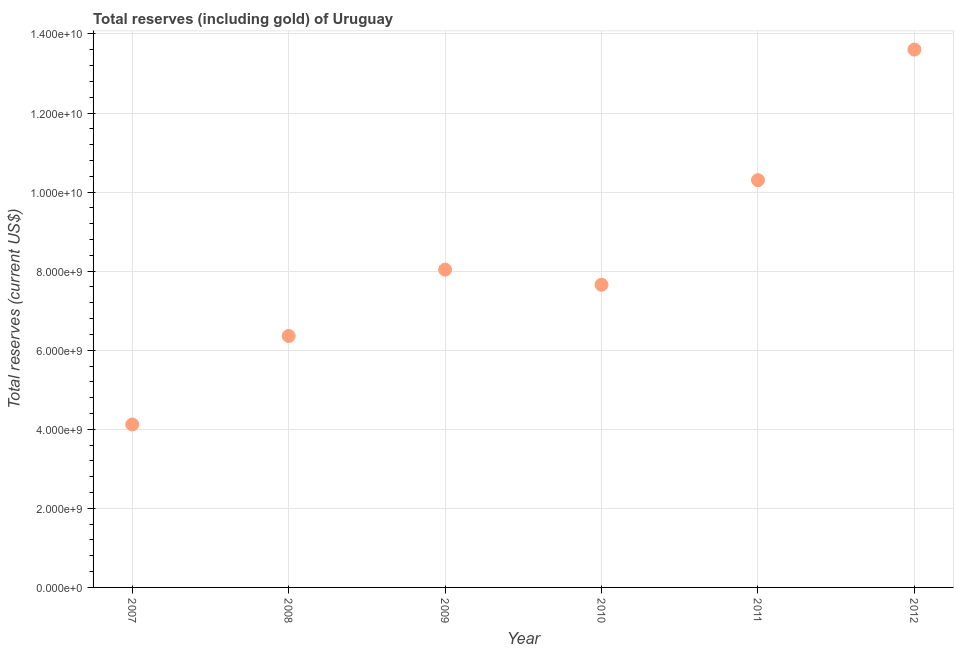What is the total reserves (including gold) in 2007?
Give a very brief answer. 4.12e+09. Across all years, what is the maximum total reserves (including gold)?
Ensure brevity in your answer.  1.36e+1. Across all years, what is the minimum total reserves (including gold)?
Your answer should be compact. 4.12e+09. In which year was the total reserves (including gold) minimum?
Give a very brief answer. 2007. What is the sum of the total reserves (including gold)?
Offer a terse response. 5.01e+1. What is the difference between the total reserves (including gold) in 2007 and 2009?
Your response must be concise. -3.92e+09. What is the average total reserves (including gold) per year?
Your answer should be compact. 8.35e+09. What is the median total reserves (including gold)?
Your answer should be very brief. 7.85e+09. Do a majority of the years between 2011 and 2008 (inclusive) have total reserves (including gold) greater than 6800000000 US$?
Your response must be concise. Yes. What is the ratio of the total reserves (including gold) in 2008 to that in 2011?
Provide a short and direct response. 0.62. Is the difference between the total reserves (including gold) in 2009 and 2012 greater than the difference between any two years?
Offer a terse response. No. What is the difference between the highest and the second highest total reserves (including gold)?
Offer a very short reply. 3.30e+09. What is the difference between the highest and the lowest total reserves (including gold)?
Ensure brevity in your answer.  9.48e+09. Does the total reserves (including gold) monotonically increase over the years?
Ensure brevity in your answer.  No. Does the graph contain any zero values?
Provide a succinct answer. No. What is the title of the graph?
Give a very brief answer. Total reserves (including gold) of Uruguay. What is the label or title of the Y-axis?
Offer a terse response. Total reserves (current US$). What is the Total reserves (current US$) in 2007?
Offer a terse response. 4.12e+09. What is the Total reserves (current US$) in 2008?
Offer a very short reply. 6.36e+09. What is the Total reserves (current US$) in 2009?
Keep it short and to the point. 8.04e+09. What is the Total reserves (current US$) in 2010?
Keep it short and to the point. 7.66e+09. What is the Total reserves (current US$) in 2011?
Ensure brevity in your answer.  1.03e+1. What is the Total reserves (current US$) in 2012?
Keep it short and to the point. 1.36e+1. What is the difference between the Total reserves (current US$) in 2007 and 2008?
Provide a short and direct response. -2.24e+09. What is the difference between the Total reserves (current US$) in 2007 and 2009?
Ensure brevity in your answer.  -3.92e+09. What is the difference between the Total reserves (current US$) in 2007 and 2010?
Give a very brief answer. -3.53e+09. What is the difference between the Total reserves (current US$) in 2007 and 2011?
Provide a succinct answer. -6.18e+09. What is the difference between the Total reserves (current US$) in 2007 and 2012?
Offer a very short reply. -9.48e+09. What is the difference between the Total reserves (current US$) in 2008 and 2009?
Provide a succinct answer. -1.68e+09. What is the difference between the Total reserves (current US$) in 2008 and 2010?
Offer a very short reply. -1.30e+09. What is the difference between the Total reserves (current US$) in 2008 and 2011?
Make the answer very short. -3.94e+09. What is the difference between the Total reserves (current US$) in 2008 and 2012?
Offer a very short reply. -7.24e+09. What is the difference between the Total reserves (current US$) in 2009 and 2010?
Your answer should be very brief. 3.82e+08. What is the difference between the Total reserves (current US$) in 2009 and 2011?
Provide a short and direct response. -2.26e+09. What is the difference between the Total reserves (current US$) in 2009 and 2012?
Give a very brief answer. -5.57e+09. What is the difference between the Total reserves (current US$) in 2010 and 2011?
Offer a very short reply. -2.65e+09. What is the difference between the Total reserves (current US$) in 2010 and 2012?
Your response must be concise. -5.95e+09. What is the difference between the Total reserves (current US$) in 2011 and 2012?
Give a very brief answer. -3.30e+09. What is the ratio of the Total reserves (current US$) in 2007 to that in 2008?
Your answer should be compact. 0.65. What is the ratio of the Total reserves (current US$) in 2007 to that in 2009?
Your answer should be very brief. 0.51. What is the ratio of the Total reserves (current US$) in 2007 to that in 2010?
Your answer should be compact. 0.54. What is the ratio of the Total reserves (current US$) in 2007 to that in 2012?
Your response must be concise. 0.3. What is the ratio of the Total reserves (current US$) in 2008 to that in 2009?
Your response must be concise. 0.79. What is the ratio of the Total reserves (current US$) in 2008 to that in 2010?
Offer a terse response. 0.83. What is the ratio of the Total reserves (current US$) in 2008 to that in 2011?
Offer a terse response. 0.62. What is the ratio of the Total reserves (current US$) in 2008 to that in 2012?
Provide a succinct answer. 0.47. What is the ratio of the Total reserves (current US$) in 2009 to that in 2011?
Offer a very short reply. 0.78. What is the ratio of the Total reserves (current US$) in 2009 to that in 2012?
Make the answer very short. 0.59. What is the ratio of the Total reserves (current US$) in 2010 to that in 2011?
Your answer should be very brief. 0.74. What is the ratio of the Total reserves (current US$) in 2010 to that in 2012?
Your response must be concise. 0.56. What is the ratio of the Total reserves (current US$) in 2011 to that in 2012?
Your response must be concise. 0.76. 